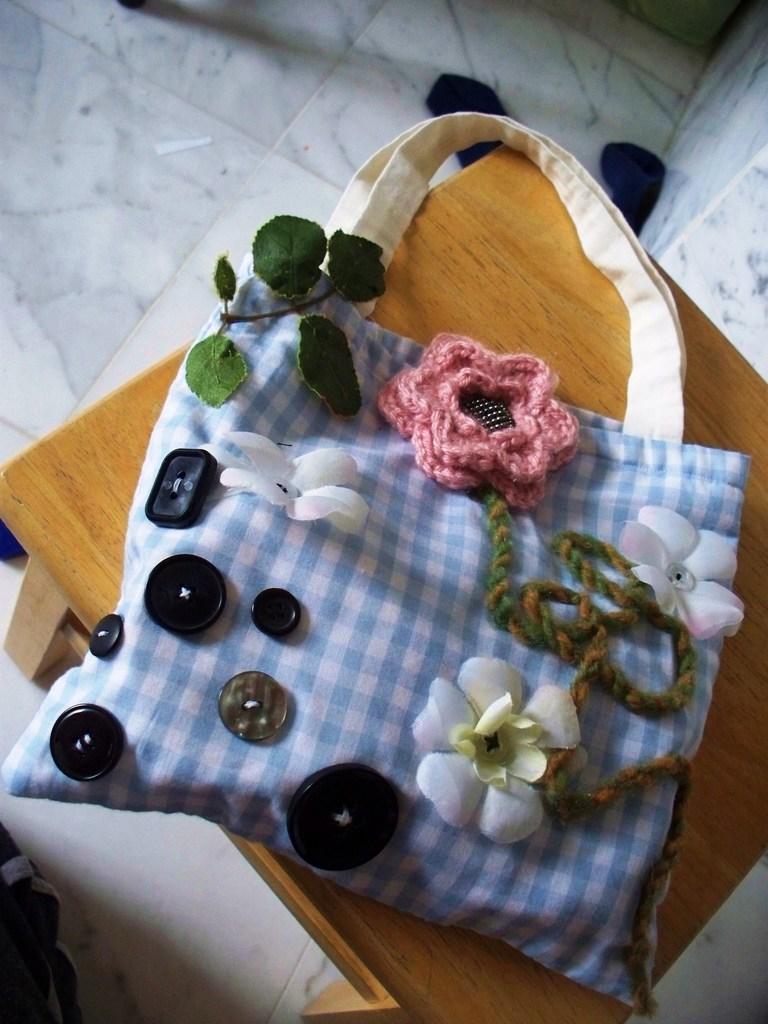In one or two sentences, can you explain what this image depicts? In the image there is a table, on table we can see a bag which is in blue and white color. On bag we can also see some leaves,flower,button in background we can see a white color tiles. 